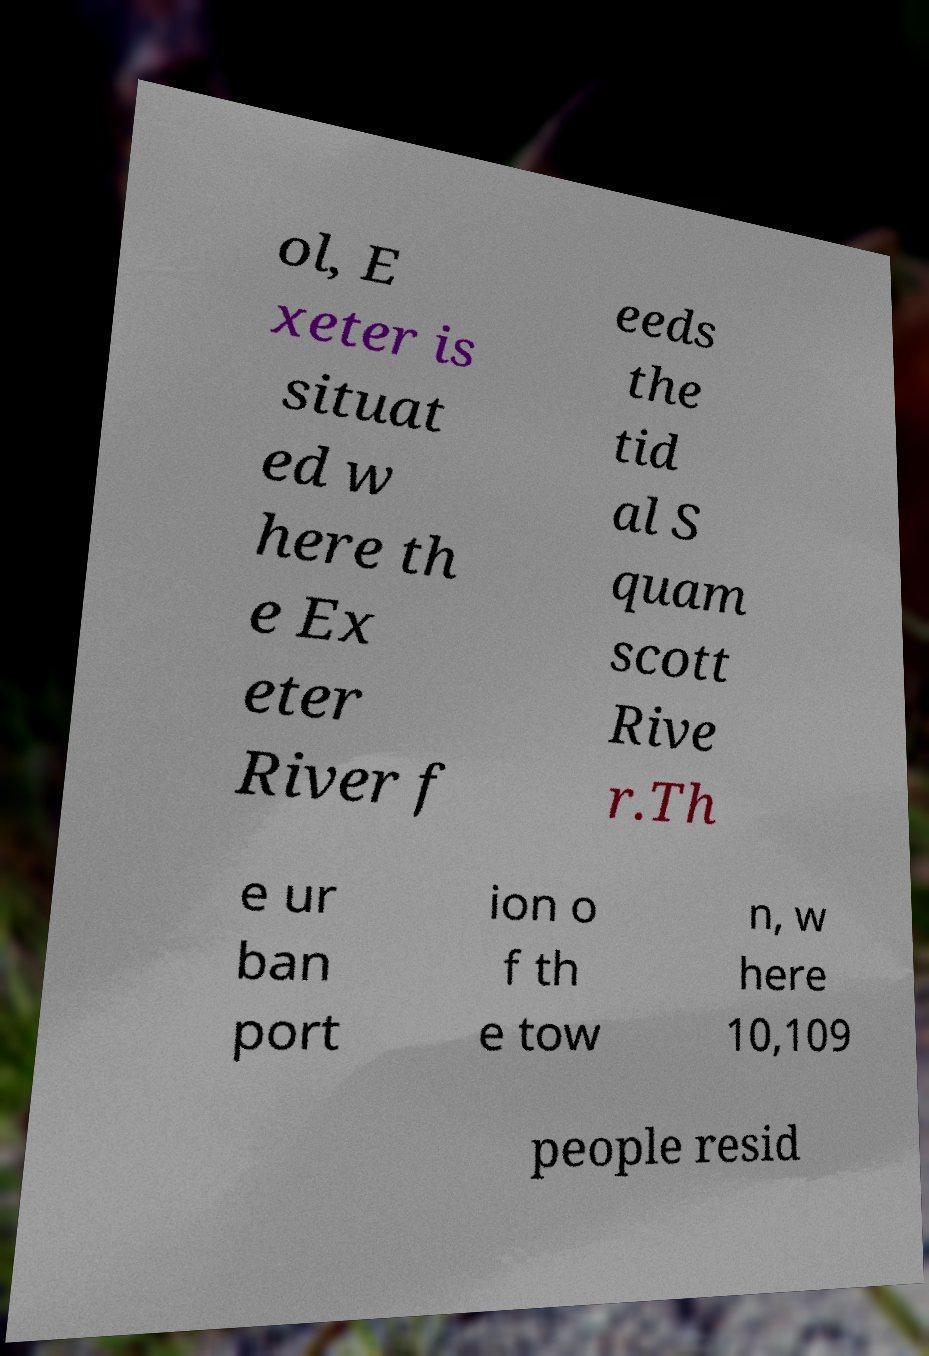Please identify and transcribe the text found in this image. ol, E xeter is situat ed w here th e Ex eter River f eeds the tid al S quam scott Rive r.Th e ur ban port ion o f th e tow n, w here 10,109 people resid 